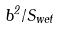Convert formula to latex. <formula><loc_0><loc_0><loc_500><loc_500>b ^ { 2 } / S _ { w e t }</formula> 